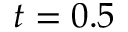<formula> <loc_0><loc_0><loc_500><loc_500>t = 0 . 5</formula> 